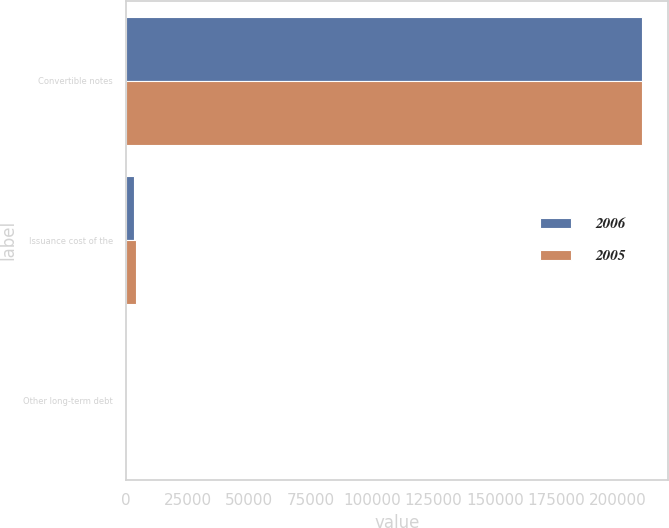Convert chart. <chart><loc_0><loc_0><loc_500><loc_500><stacked_bar_chart><ecel><fcel>Convertible notes<fcel>Issuance cost of the<fcel>Other long-term debt<nl><fcel>2006<fcel>210000<fcel>2993<fcel>17<nl><fcel>2005<fcel>210000<fcel>3869<fcel>24<nl></chart> 